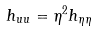Convert formula to latex. <formula><loc_0><loc_0><loc_500><loc_500>h _ { u u } = \eta ^ { 2 } h _ { \eta \eta }</formula> 